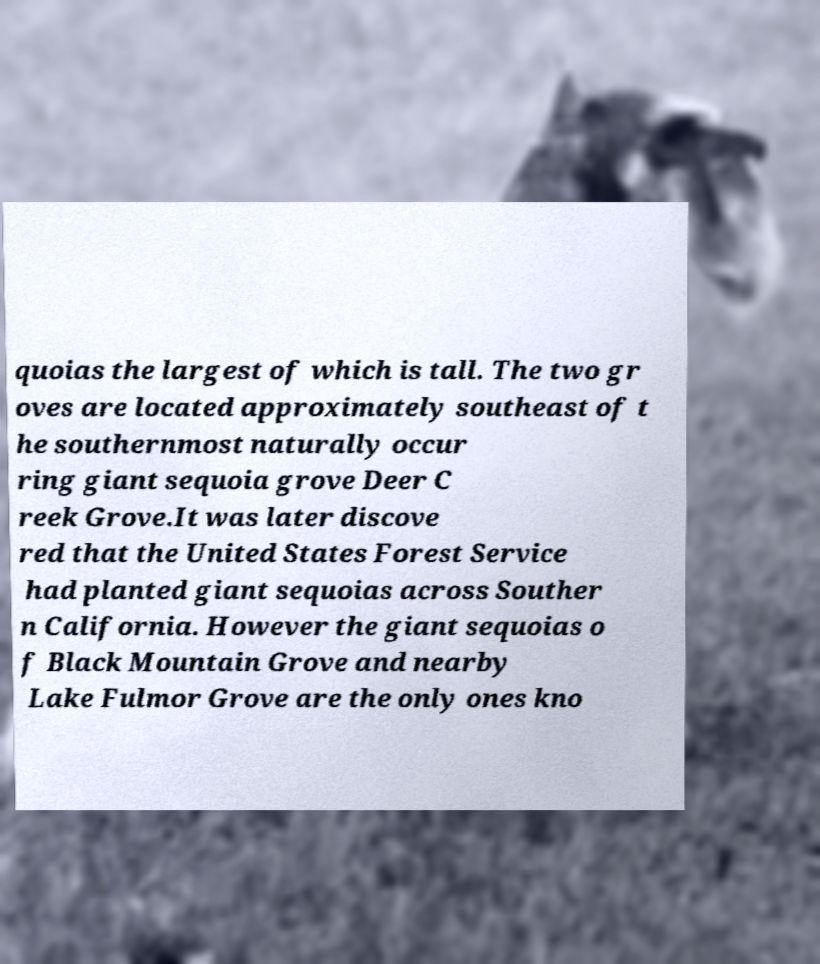Could you assist in decoding the text presented in this image and type it out clearly? quoias the largest of which is tall. The two gr oves are located approximately southeast of t he southernmost naturally occur ring giant sequoia grove Deer C reek Grove.It was later discove red that the United States Forest Service had planted giant sequoias across Souther n California. However the giant sequoias o f Black Mountain Grove and nearby Lake Fulmor Grove are the only ones kno 